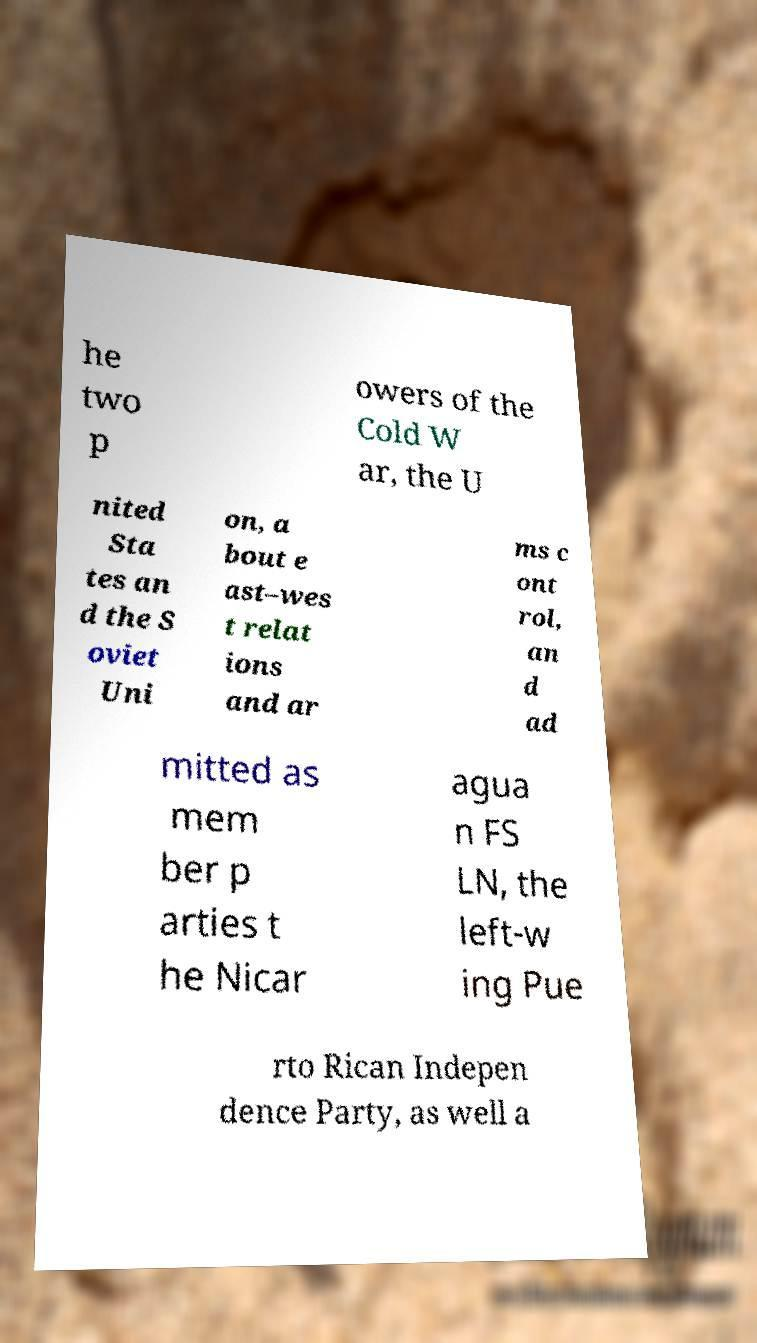Can you accurately transcribe the text from the provided image for me? he two p owers of the Cold W ar, the U nited Sta tes an d the S oviet Uni on, a bout e ast–wes t relat ions and ar ms c ont rol, an d ad mitted as mem ber p arties t he Nicar agua n FS LN, the left-w ing Pue rto Rican Indepen dence Party, as well a 